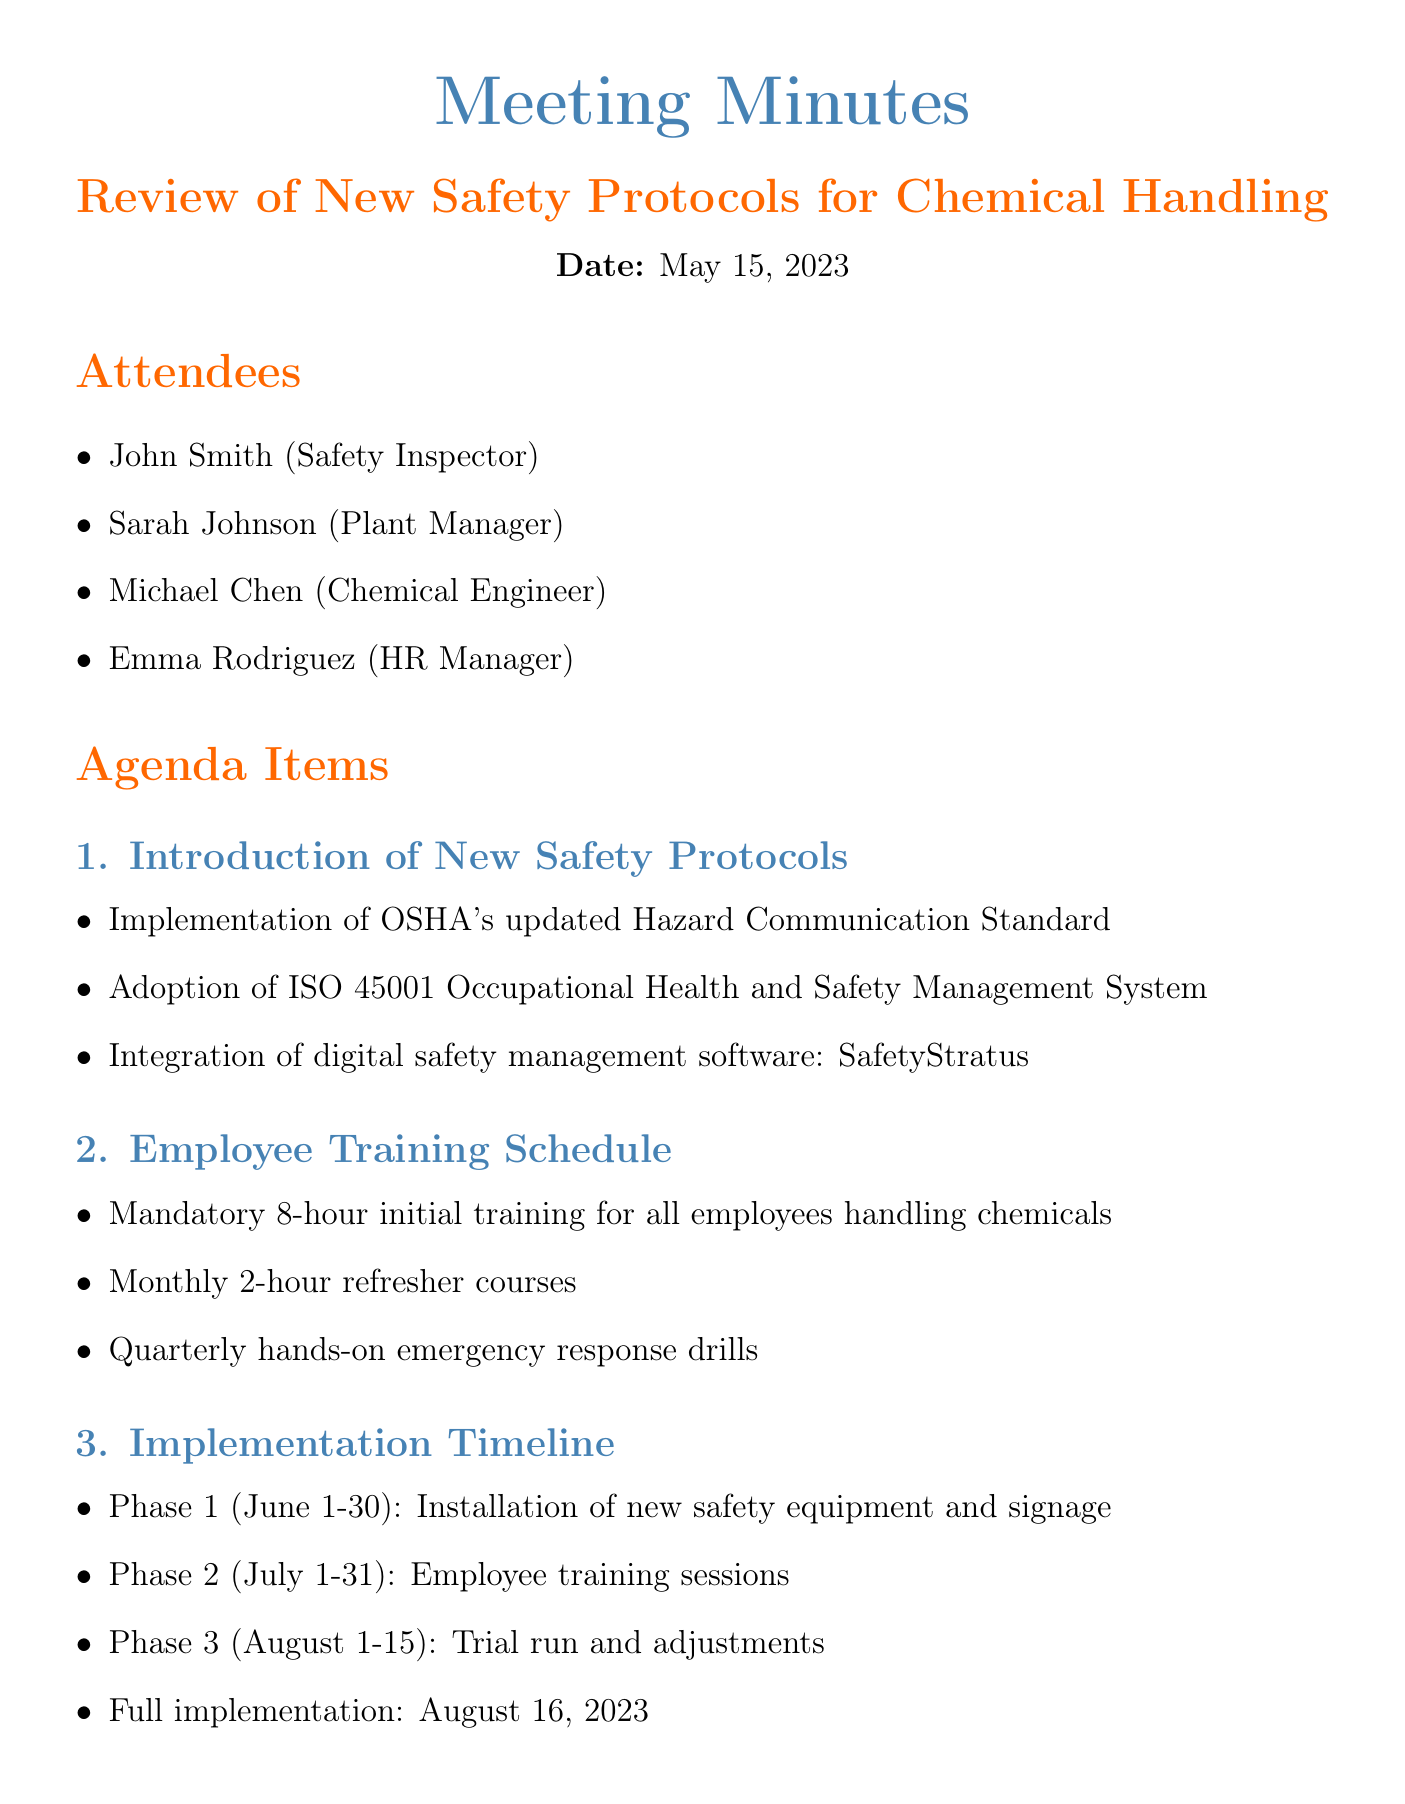what is the date of the meeting? The date of the meeting is explicitly mentioned in the document under the heading "Date."
Answer: May 15, 2023 who is the HR Manager present in the meeting? The attendees section lists the individuals present, including their roles.
Answer: Emma Rodriguez what is the total budget for the new safety protocols? The budget allocation section states the total budget required for the safety protocols.
Answer: $500,000 how long will the initial training for employees last? The employee training schedule details the duration of the initial mandatory training for chemical handling.
Answer: 8-hour when is the full implementation of the new protocols scheduled? The implementation timeline specifies the date for full implementation of the new safety protocols.
Answer: August 16, 2023 what is one key safety improvement mentioned in the meeting? The key safety improvements section lists specific enhancements proposed during the meeting.
Answer: Honeywell gas detection systems what is the cost allocated for training and certification? The budget allocation section provides breakdowns of costs, including training and certification expenses.
Answer: $150,000 who is responsible for conducting weekly progress checks? The action items list assigns specific responsibilities to individuals for oversight and coordination.
Answer: John Smith what phase occurs between July 1-31? The implementation timeline outlines the different phases and their respective dates.
Answer: Employee training sessions 